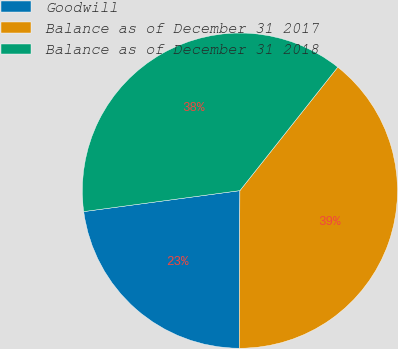Convert chart to OTSL. <chart><loc_0><loc_0><loc_500><loc_500><pie_chart><fcel>Goodwill<fcel>Balance as of December 31 2017<fcel>Balance as of December 31 2018<nl><fcel>22.81%<fcel>39.4%<fcel>37.79%<nl></chart> 